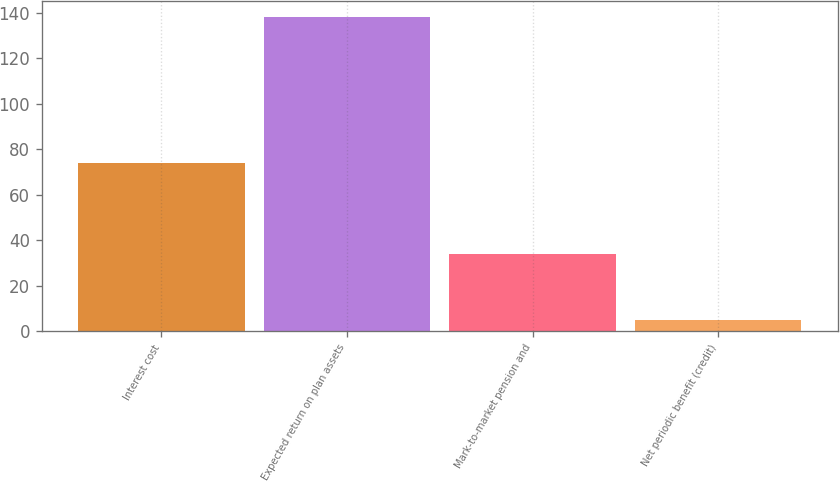Convert chart. <chart><loc_0><loc_0><loc_500><loc_500><bar_chart><fcel>Interest cost<fcel>Expected return on plan assets<fcel>Mark-to-market pension and<fcel>Net periodic benefit (credit)<nl><fcel>74<fcel>138<fcel>34<fcel>5<nl></chart> 